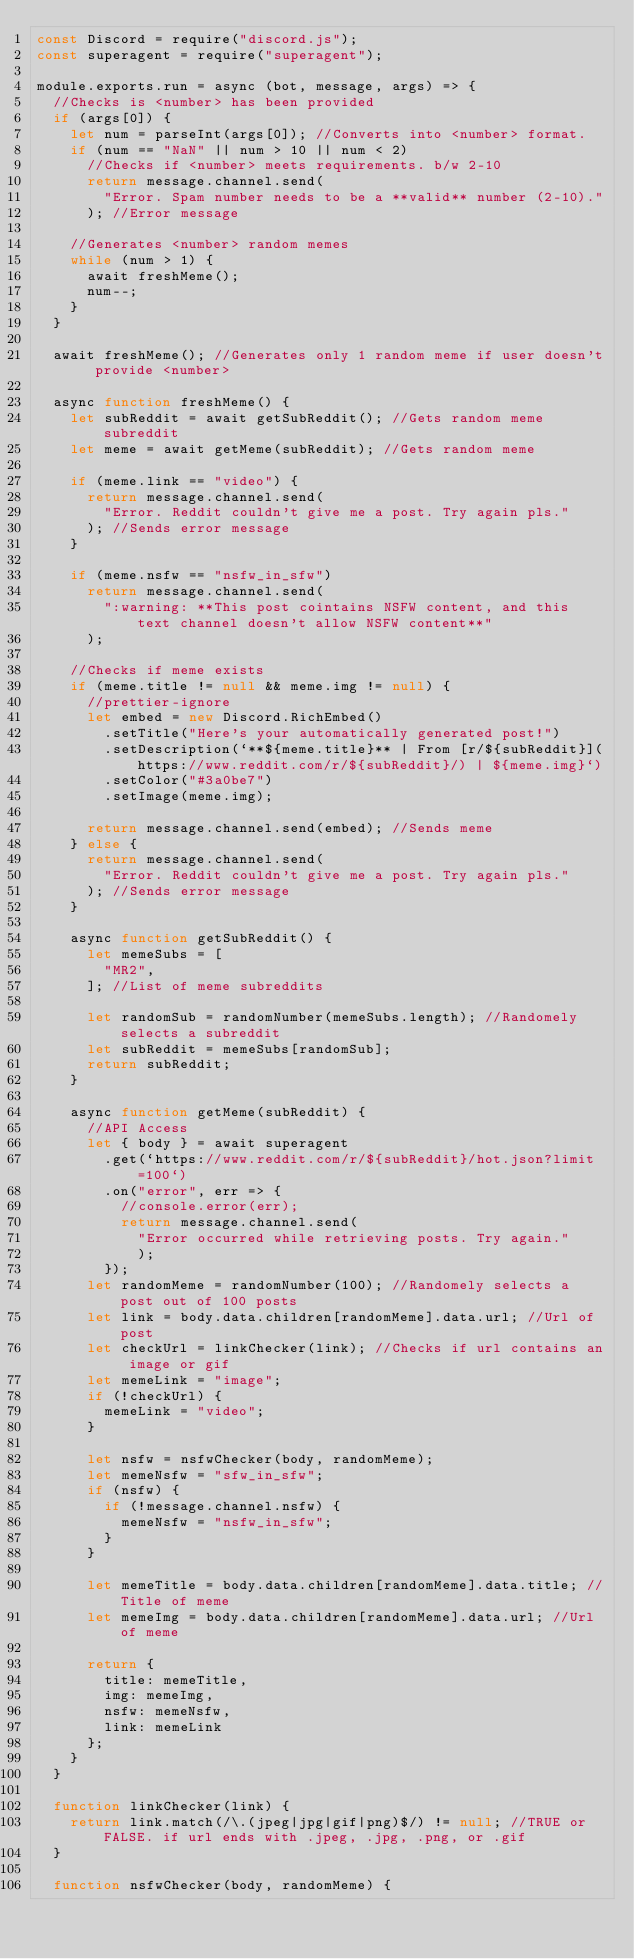Convert code to text. <code><loc_0><loc_0><loc_500><loc_500><_JavaScript_>const Discord = require("discord.js");
const superagent = require("superagent");

module.exports.run = async (bot, message, args) => {
  //Checks is <number> has been provided
  if (args[0]) {
    let num = parseInt(args[0]); //Converts into <number> format.
    if (num == "NaN" || num > 10 || num < 2)
      //Checks if <number> meets requirements. b/w 2-10
      return message.channel.send(
        "Error. Spam number needs to be a **valid** number (2-10)."
      ); //Error message

    //Generates <number> random memes
    while (num > 1) {
      await freshMeme();
      num--;
    }
  }

  await freshMeme(); //Generates only 1 random meme if user doesn't provide <number>

  async function freshMeme() {
    let subReddit = await getSubReddit(); //Gets random meme subreddit
    let meme = await getMeme(subReddit); //Gets random meme

    if (meme.link == "video") {
      return message.channel.send(
        "Error. Reddit couldn't give me a post. Try again pls."
      ); //Sends error message
    }

    if (meme.nsfw == "nsfw_in_sfw")
      return message.channel.send(
        ":warning: **This post cointains NSFW content, and this text channel doesn't allow NSFW content**"
      );

    //Checks if meme exists
    if (meme.title != null && meme.img != null) {
      //prettier-ignore
      let embed = new Discord.RichEmbed()
        .setTitle("Here's your automatically generated post!")
        .setDescription(`**${meme.title}** | From [r/${subReddit}](https://www.reddit.com/r/${subReddit}/) | ${meme.img}`)
        .setColor("#3a0be7")
        .setImage(meme.img);

      return message.channel.send(embed); //Sends meme
    } else {
      return message.channel.send(
        "Error. Reddit couldn't give me a post. Try again pls."
      ); //Sends error message
    }

    async function getSubReddit() {
      let memeSubs = [
        "MR2",
      ]; //List of meme subreddits

      let randomSub = randomNumber(memeSubs.length); //Randomely selects a subreddit
      let subReddit = memeSubs[randomSub];
      return subReddit;
    }

    async function getMeme(subReddit) {
      //API Access
      let { body } = await superagent
        .get(`https://www.reddit.com/r/${subReddit}/hot.json?limit=100`)
        .on("error", err => {
          //console.error(err);
          return message.channel.send(
            "Error occurred while retrieving posts. Try again."
            );
        });
      let randomMeme = randomNumber(100); //Randomely selects a post out of 100 posts
      let link = body.data.children[randomMeme].data.url; //Url of post
      let checkUrl = linkChecker(link); //Checks if url contains an image or gif
      let memeLink = "image";
      if (!checkUrl) {
        memeLink = "video";
      }

      let nsfw = nsfwChecker(body, randomMeme);
      let memeNsfw = "sfw_in_sfw";
      if (nsfw) {
        if (!message.channel.nsfw) {
          memeNsfw = "nsfw_in_sfw";
        }
      }

      let memeTitle = body.data.children[randomMeme].data.title; //Title of meme
      let memeImg = body.data.children[randomMeme].data.url; //Url of meme

      return {
        title: memeTitle,
        img: memeImg,
        nsfw: memeNsfw,
        link: memeLink
      };
    }
  }

  function linkChecker(link) {
    return link.match(/\.(jpeg|jpg|gif|png)$/) != null; //TRUE or FALSE. if url ends with .jpeg, .jpg, .png, or .gif
  }

  function nsfwChecker(body, randomMeme) {</code> 